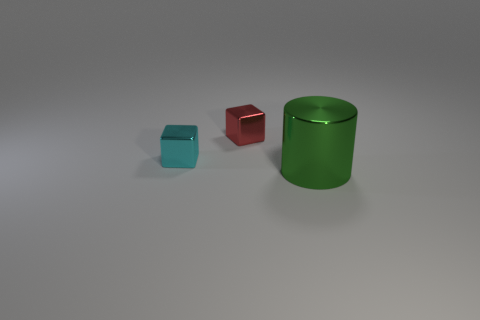Subtract all red blocks. How many blocks are left? 1 Add 3 large blue metallic spheres. How many objects exist? 6 Subtract all cylinders. How many objects are left? 2 Add 2 tiny cyan objects. How many tiny cyan objects are left? 3 Add 1 red cylinders. How many red cylinders exist? 1 Subtract 0 brown cylinders. How many objects are left? 3 Subtract all brown cylinders. Subtract all cyan cubes. How many cylinders are left? 1 Subtract all large green spheres. Subtract all small metal blocks. How many objects are left? 1 